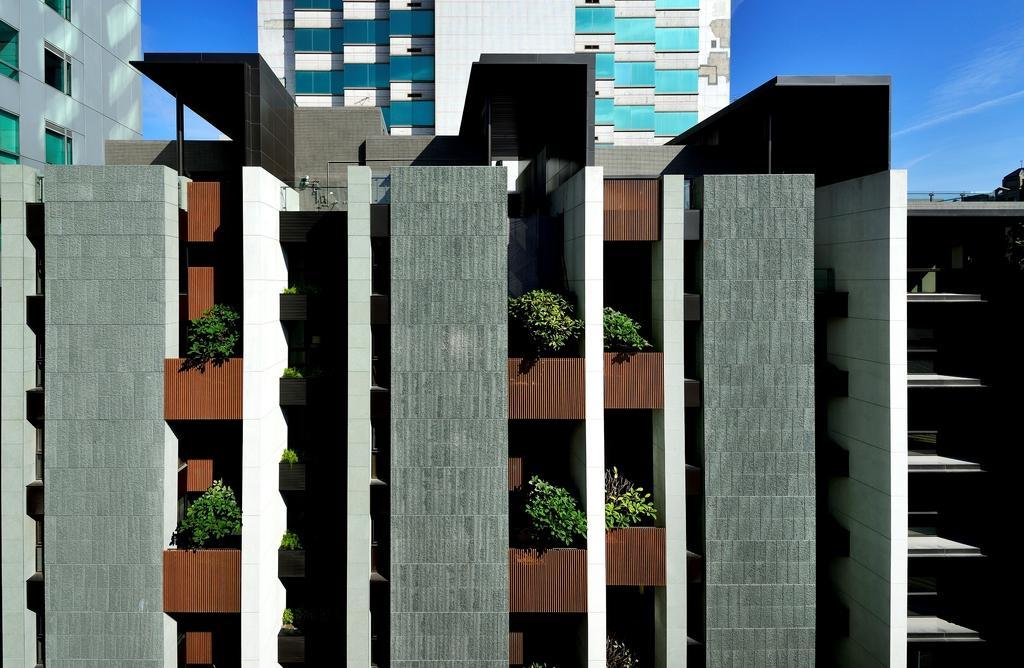Could you give a brief overview of what you see in this image? In the picture there is a building and there are few plants in the balcony of the building, behind that there is a tall tower and it has plenty of windows. 